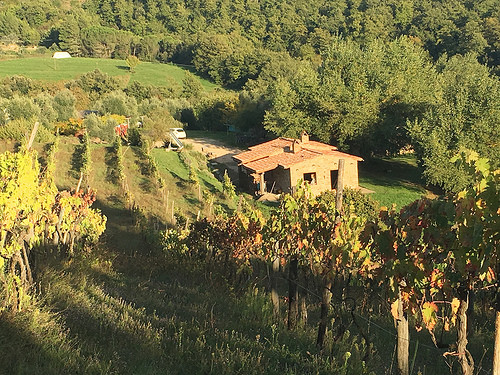<image>
Is the house in front of the tree? No. The house is not in front of the tree. The spatial positioning shows a different relationship between these objects. 